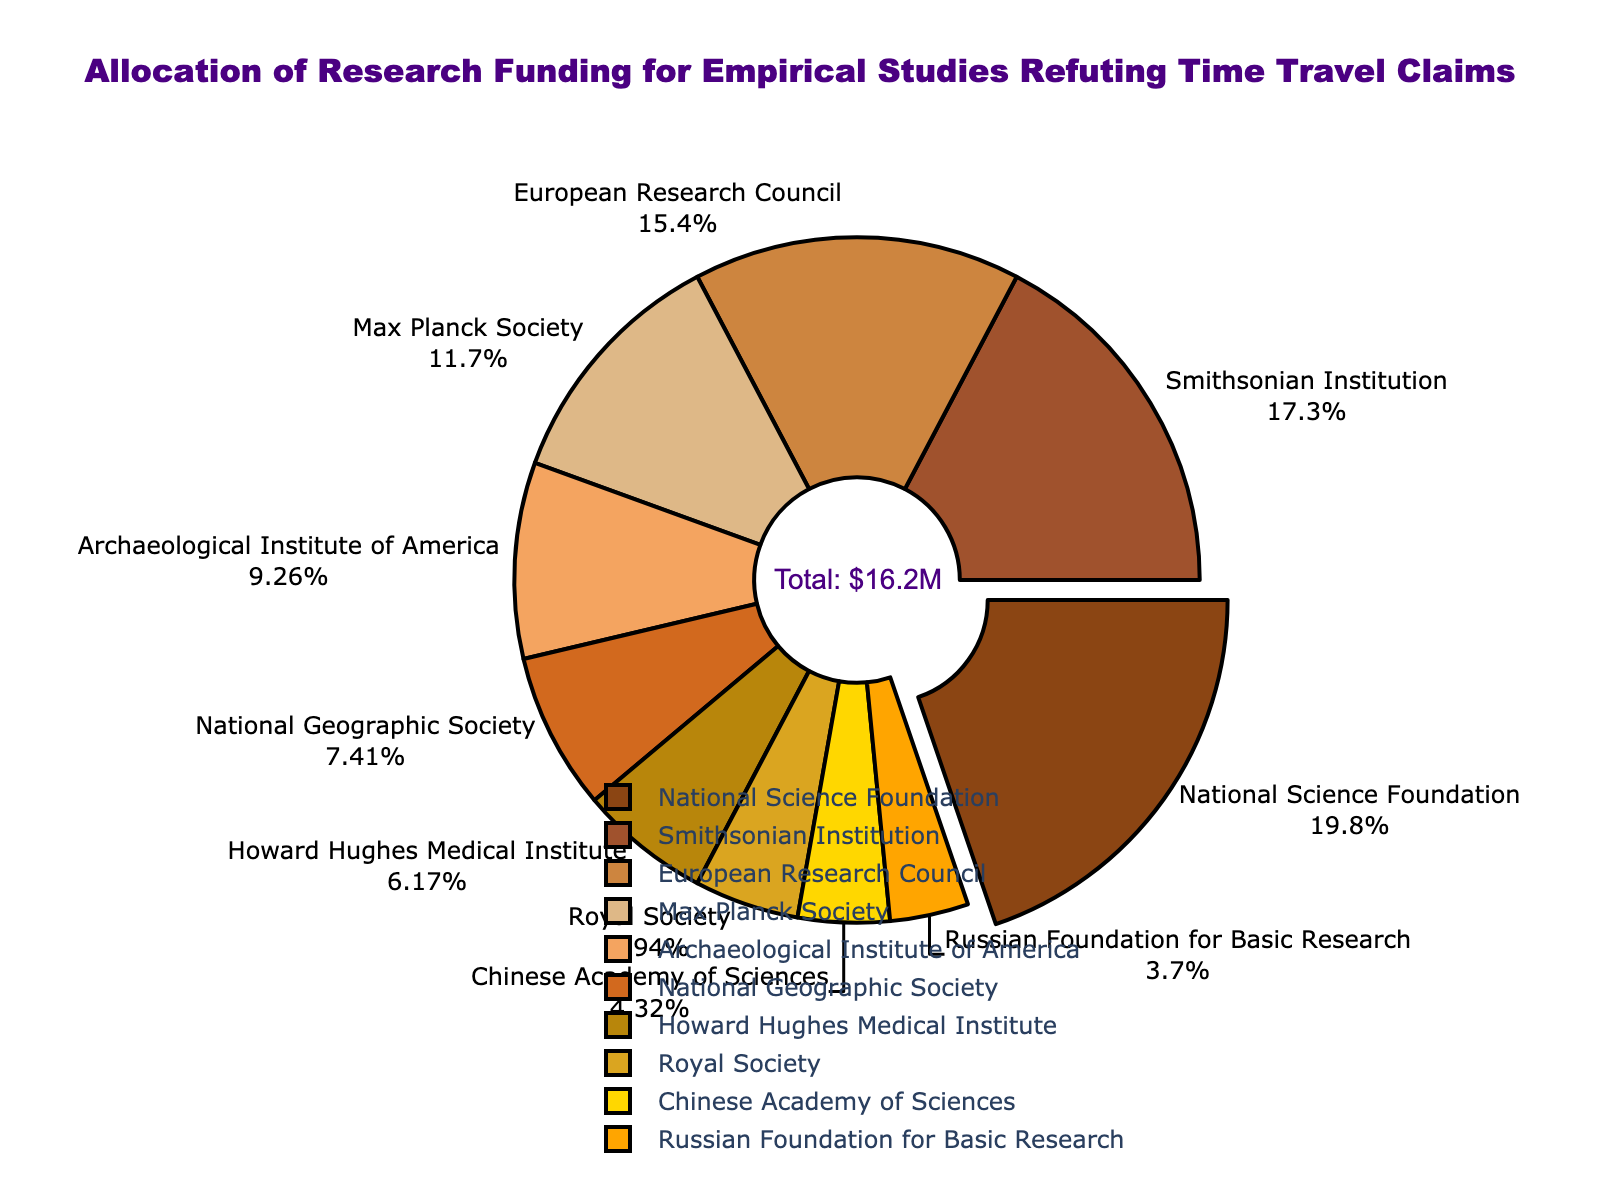What's the total amount of research funding allocated according to the pie chart? The chart indicates the total funding by including an annotation in the center: "Total: $16.2M". This total is the sum of all the individual fund amounts listed.
Answer: $16.2M Which organization contributed the highest amount of funding and how much did they contribute? The National Science Foundation has a pulled-out section from the pie, indicating it contributes the highest amount. The label indicates it contributed $3.2M.
Answer: National Science Foundation, $3.2M What's the combined funding from European Research Council and Max Planck Society? The funding from the European Research Council is $2.5M, and from the Max Planck Society is $1.9M. Summing these gives $2.5M + $1.9M = $4.4M.
Answer: $4.4M Which funding source contributes less than $1M, and what's the total amount from these sources? The Royal Society, Chinese Academy of Sciences, and Russian Foundation for Basic Research each contribute less than $1M ($0.8M, $0.7M, and $0.6M respectively). Summing them gives $0.8M + $0.7M + $0.6M = $2.1M.
Answer: Royal Society, Chinese Academy of Sciences, Russian Foundation for Basic Research, $2.1M What percentage of the total funding does the Archaeological Institute of America contribute? The Archaeological Institute of America contributes $1.5M. To find the percentage, divide this by the total funding ($16.2M) and multiply by 100: ($1.5M / $16.2M) * 100 ≈ 9.26%.
Answer: 9.26% Compare the funding provided by the Smithsonian Institution and the National Geographic Society. Which one is greater and by how much? The Smithsonian Institution contributes $2.8M and the National Geographic Society $1.2M. The difference is $2.8M - $1.2M = $1.6M.
Answer: Smithsonian Institution, $1.6M How many funding sources contribute more than $2M? Funding sources with contributions more than $2M are the National Science Foundation ($3.2M), Smithsonian Institution ($2.8M), and European Research Council ($2.5M). There are 3 of them.
Answer: 3 What's the sum of contributions from the Howard Hughes Medical Institute and the National Geographical Society? The Howard Hughes Medical Institute contributes $1.0M, and the National Geographical Society contributes $1.2M. Adding these gives $1.0M + $1.2M = $2.2M.
Answer: $2.2M Which segment appears in golden color and what is its contribution? The segment for National Geographic Society is in a golden color, contributing $1.2M as indicated by its label.
Answer: National Geographic Society, $1.2M How much more funding does the National Science Foundation contribute compared to the Russian Foundation for Basic Research? The National Science Foundation contributes $3.2M and the Russian Foundation for Basic Research contributes $0.6M. The difference is $3.2M - $0.6M = $2.6M.
Answer: $2.6M 